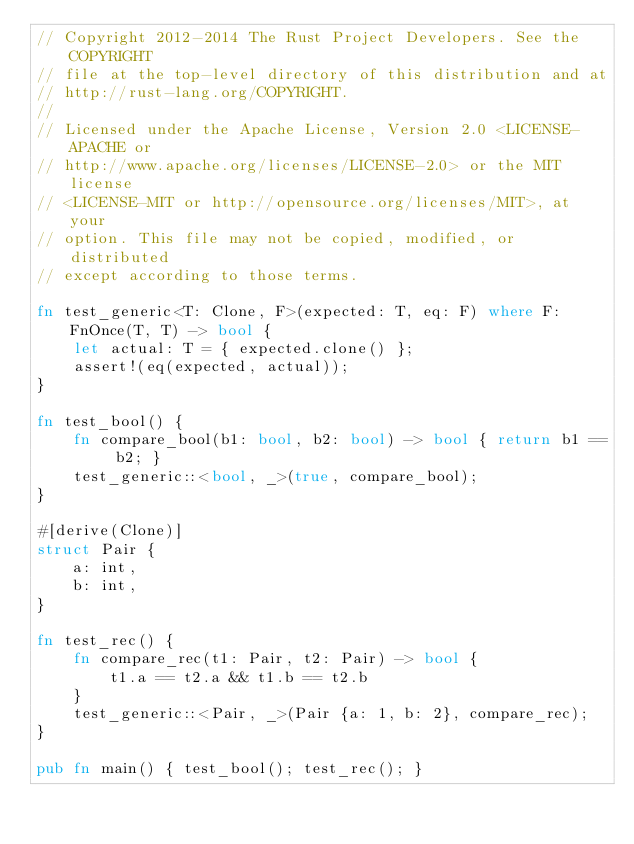<code> <loc_0><loc_0><loc_500><loc_500><_Rust_>// Copyright 2012-2014 The Rust Project Developers. See the COPYRIGHT
// file at the top-level directory of this distribution and at
// http://rust-lang.org/COPYRIGHT.
//
// Licensed under the Apache License, Version 2.0 <LICENSE-APACHE or
// http://www.apache.org/licenses/LICENSE-2.0> or the MIT license
// <LICENSE-MIT or http://opensource.org/licenses/MIT>, at your
// option. This file may not be copied, modified, or distributed
// except according to those terms.

fn test_generic<T: Clone, F>(expected: T, eq: F) where F: FnOnce(T, T) -> bool {
    let actual: T = { expected.clone() };
    assert!(eq(expected, actual));
}

fn test_bool() {
    fn compare_bool(b1: bool, b2: bool) -> bool { return b1 == b2; }
    test_generic::<bool, _>(true, compare_bool);
}

#[derive(Clone)]
struct Pair {
    a: int,
    b: int,
}

fn test_rec() {
    fn compare_rec(t1: Pair, t2: Pair) -> bool {
        t1.a == t2.a && t1.b == t2.b
    }
    test_generic::<Pair, _>(Pair {a: 1, b: 2}, compare_rec);
}

pub fn main() { test_bool(); test_rec(); }
</code> 